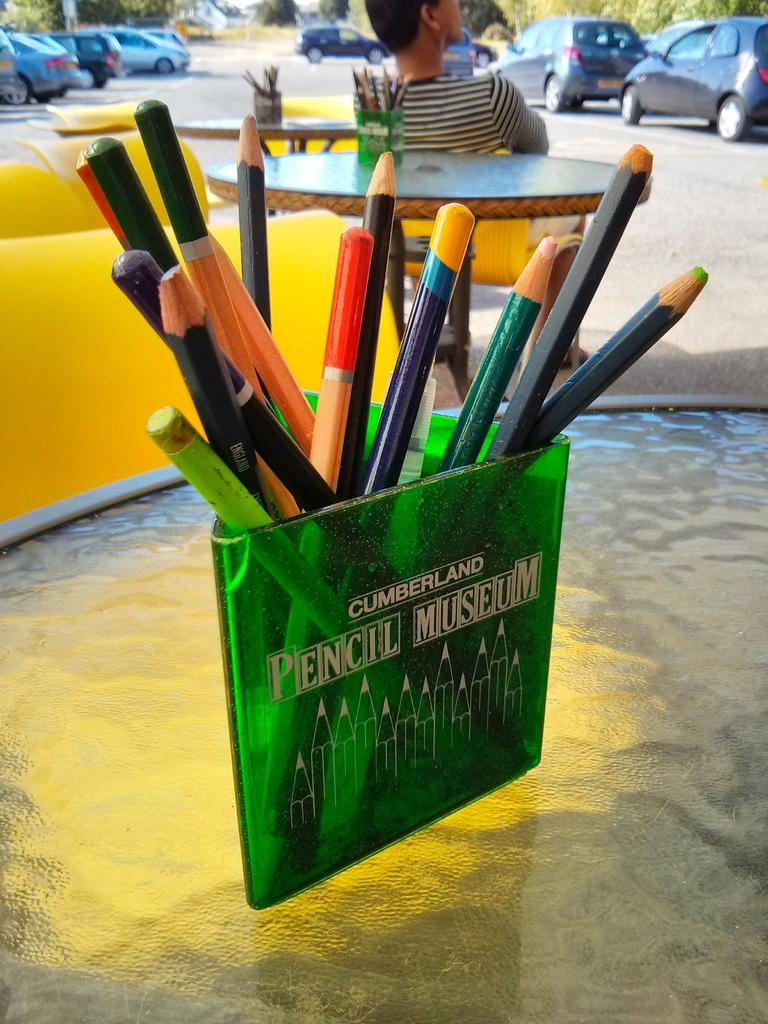What can be found on the tables in the image? There are pencils in pencil stands on the tables. What type of furniture is present in the image? There are chairs in the image. Is anyone sitting on the chairs? Yes, a person is sitting on a chair. What is parked on the path in the image? There are vehicles parked on the path. What type of natural elements can be seen in the image? There are trees in the image. Is there a hill visible in the image? There is no hill present in the image. What angle is the person sitting at in the image? The angle at which the person is sitting cannot be determined from the image. 